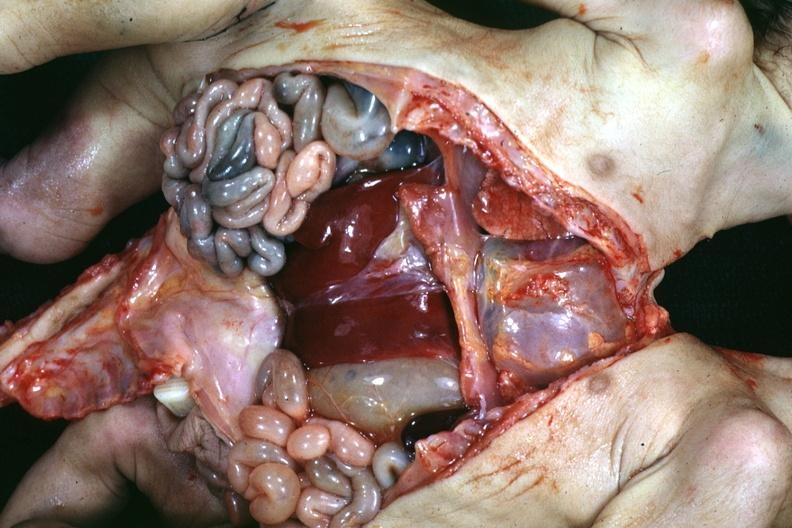how many sets is lower chest and abdomen anterior opened lower chest and abdomen showing apparent intestine with one liver?
Answer the question using a single word or phrase. Two 